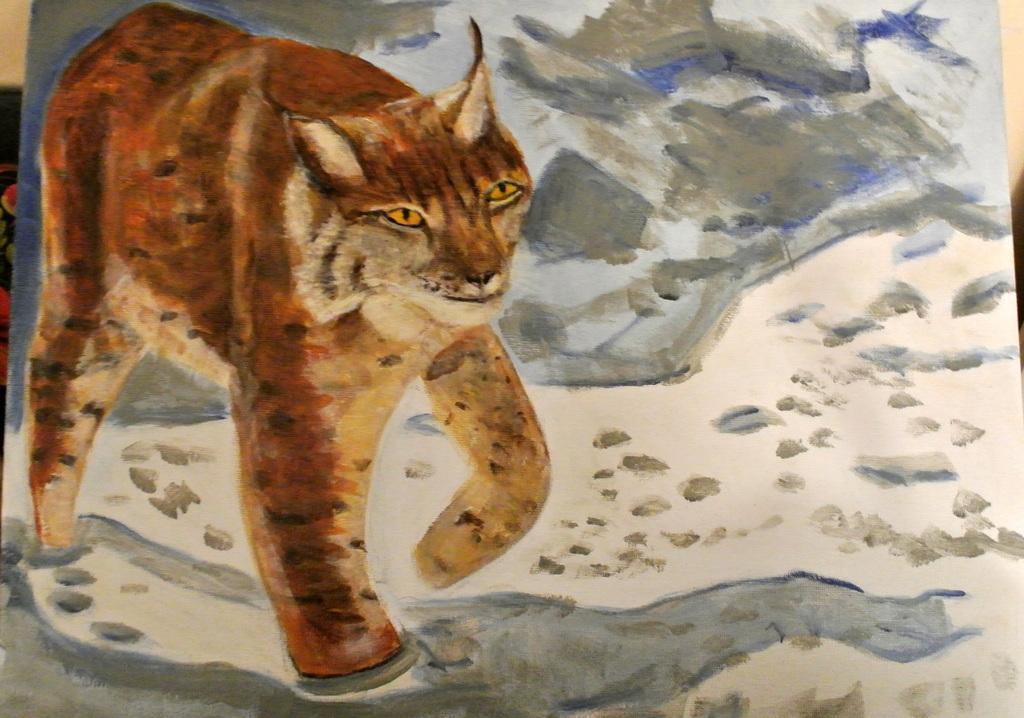Can you describe this image briefly? In the foreground of this image, there is a painted paper where there is a tiger and water on it. In the background, there is a wall. 